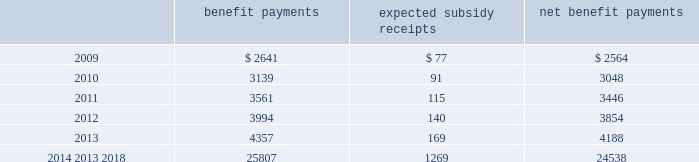Mastercard incorporated notes to consolidated financial statements 2014 ( continued ) ( in thousands , except percent and per share data ) the company does not make any contributions to its postretirement plan other than funding benefits payments .
The table summarizes expected net benefit payments from the company 2019s general assets through 2018 : benefit payments expected subsidy receipts benefit payments .
The company provides limited postemployment benefits to eligible former u.s .
Employees , primarily severance under a formal severance plan ( the 201cseverance plan 201d ) .
The company accounts for severance expense in accordance with sfas no .
112 , 201cemployers 2019 accounting for postemployment benefits 201d by accruing the expected cost of the severance benefits expected to be provided to former employees after employment over their relevant service periods .
The company updates the assumptions in determining the severance accrual by evaluating the actual severance activity and long-term trends underlying the assumptions .
As a result of updating the assumptions , the company recorded severance expense ( benefit ) related to the severance plan of $ 2643 , $ ( 3418 ) and $ 8400 , respectively , during the years 2008 , 2007 and 2006 .
The company has an accrued liability related to the severance plan and other severance obligations in the amount of $ 63863 and $ 56172 at december 31 , 2008 and 2007 , respectively .
Note 13 .
Debt on april 28 , 2008 , the company extended its committed unsecured revolving credit facility , dated as of april 28 , 2006 ( the 201ccredit facility 201d ) , for an additional year .
The new expiration date of the credit facility is april 26 , 2011 .
The available funding under the credit facility will remain at $ 2500000 through april 27 , 2010 and then decrease to $ 2000000 during the final year of the credit facility agreement .
Other terms and conditions in the credit facility remain unchanged .
The company 2019s option to request that each lender under the credit facility extend its commitment was provided pursuant to the original terms of the credit facility agreement .
Borrowings under the facility are available to provide liquidity in the event of one or more settlement failures by mastercard international customers and , subject to a limit of $ 500000 , for general corporate purposes .
A facility fee of 8 basis points on the total commitment , or approximately $ 2030 , is paid annually .
Interest on borrowings under the credit facility would be charged at the london interbank offered rate ( libor ) plus an applicable margin of 37 basis points or an alternative base rate , and a utilization fee of 10 basis points would be charged if outstanding borrowings under the facility exceed 50% ( 50 % ) of commitments .
The facility fee and borrowing cost are contingent upon the company 2019s credit rating .
The company also agreed to pay upfront fees of $ 1250 and administrative fees of $ 325 for the credit facility which are being amortized straight- line over three years .
Facility and other fees associated with the credit facility or prior facilities totaled $ 2353 , $ 2477 and $ 2717 for each of the years ended december 31 , 2008 , 2007 and 2006 , respectively .
Mastercard was in compliance with the covenants of the credit facility and had no borrowings under the credit facility at december 31 , 2008 or december 31 , 2007 .
The majority of credit facility lenders are customers or affiliates of customers of mastercard international .
In june 1998 , mastercard international issued ten-year unsecured , subordinated notes ( the 201cnotes 201d ) paying a fixed interest rate of 6.67% ( 6.67 % ) per annum .
Mastercard repaid the entire principal amount of $ 80000 on june 30 .
What is the variation observed in the net benefit payments during 2012 and 2011? 
Rationale: it is the difference between those values of net benefit payments .
Computations: (3854 - 3446)
Answer: 408.0. 